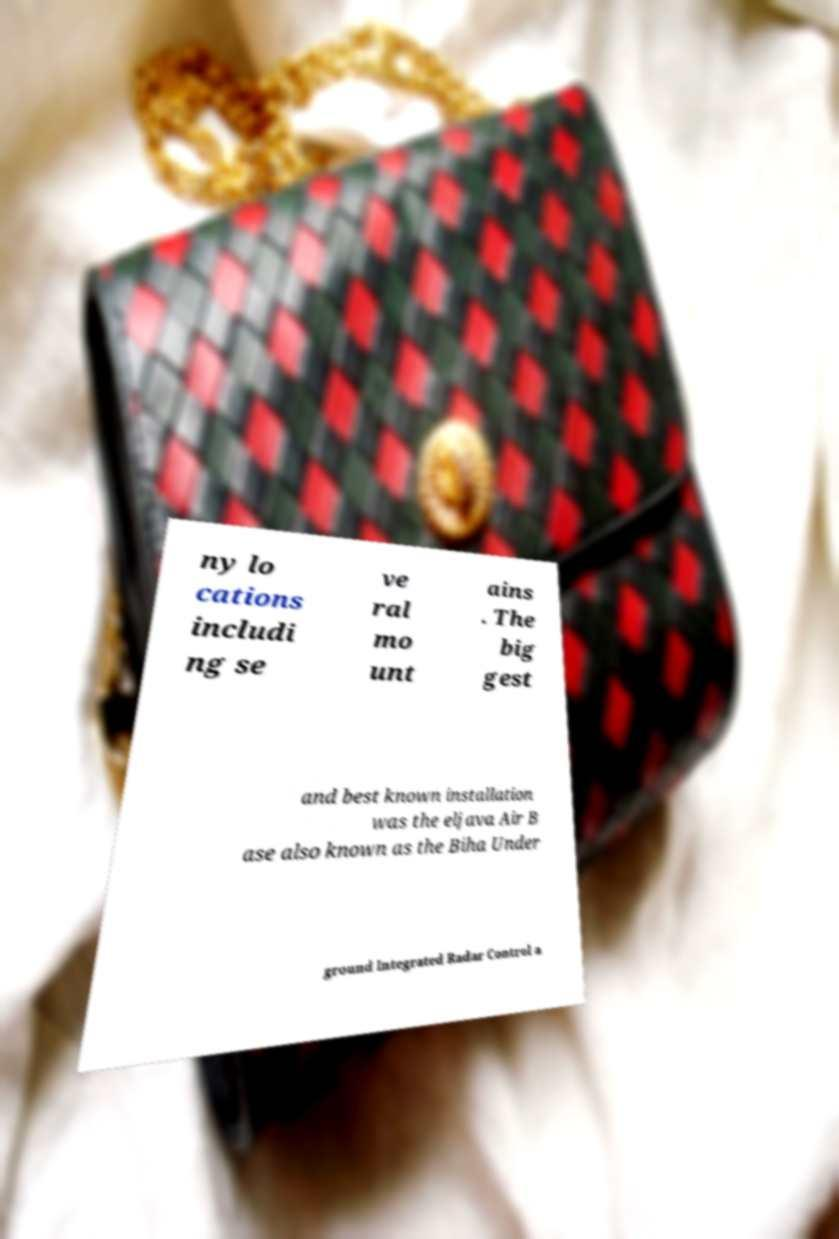For documentation purposes, I need the text within this image transcribed. Could you provide that? ny lo cations includi ng se ve ral mo unt ains . The big gest and best known installation was the eljava Air B ase also known as the Biha Under ground Integrated Radar Control a 